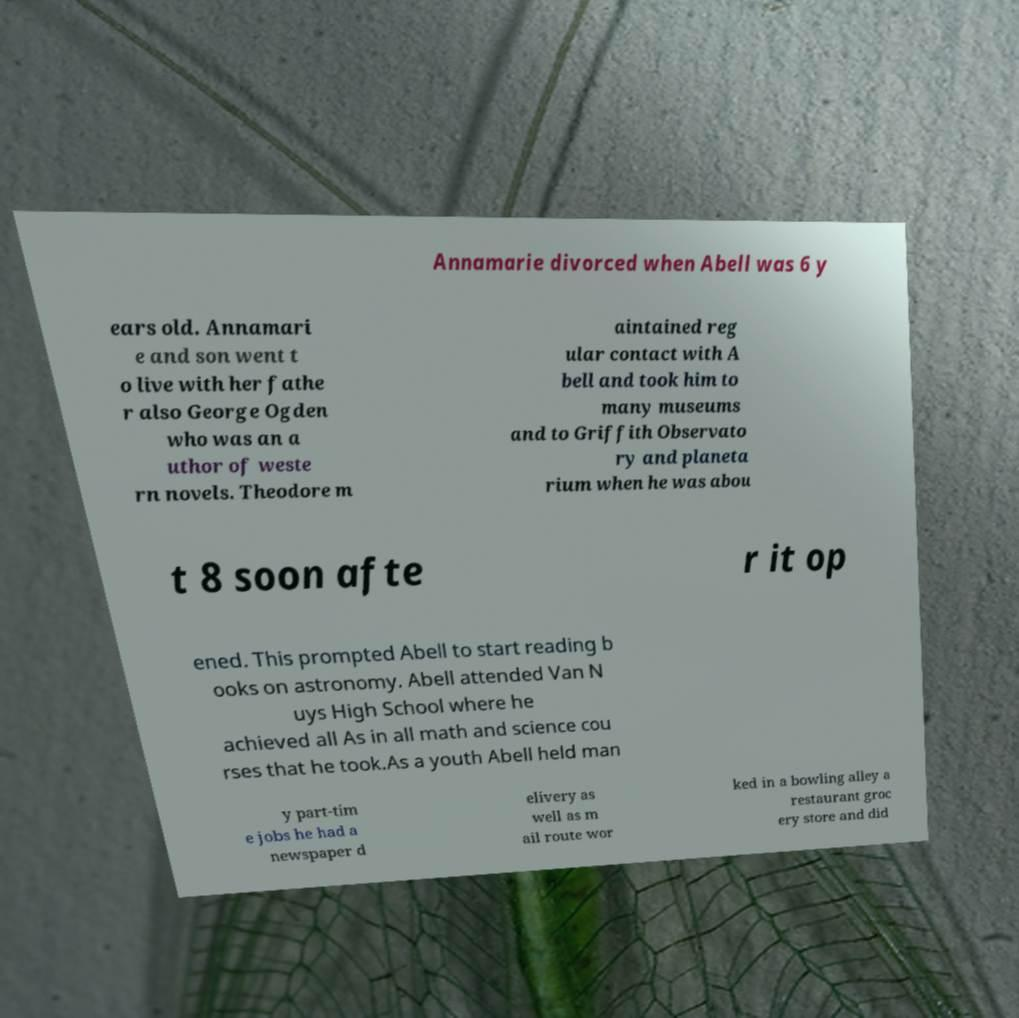What messages or text are displayed in this image? I need them in a readable, typed format. Annamarie divorced when Abell was 6 y ears old. Annamari e and son went t o live with her fathe r also George Ogden who was an a uthor of weste rn novels. Theodore m aintained reg ular contact with A bell and took him to many museums and to Griffith Observato ry and planeta rium when he was abou t 8 soon afte r it op ened. This prompted Abell to start reading b ooks on astronomy. Abell attended Van N uys High School where he achieved all As in all math and science cou rses that he took.As a youth Abell held man y part-tim e jobs he had a newspaper d elivery as well as m ail route wor ked in a bowling alley a restaurant groc ery store and did 